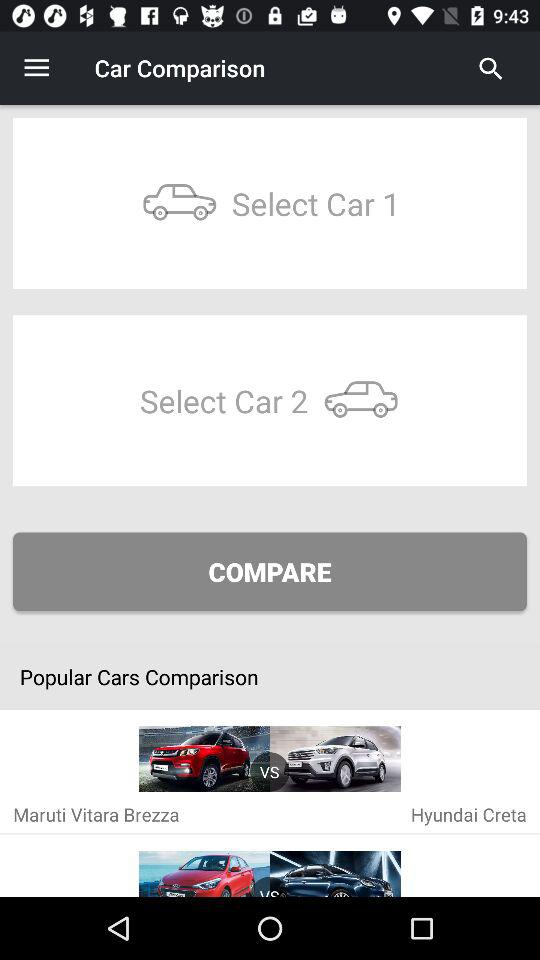How many cars are being compared?
Answer the question using a single word or phrase. 2 